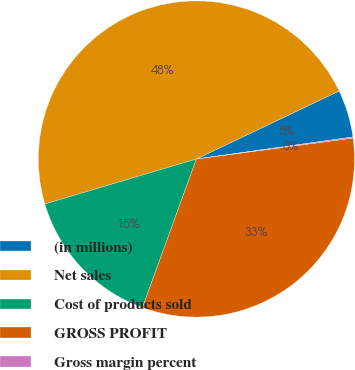Convert chart to OTSL. <chart><loc_0><loc_0><loc_500><loc_500><pie_chart><fcel>(in millions)<fcel>Net sales<fcel>Cost of products sold<fcel>GROSS PROFIT<fcel>Gross margin percent<nl><fcel>4.85%<fcel>47.52%<fcel>14.86%<fcel>32.66%<fcel>0.11%<nl></chart> 